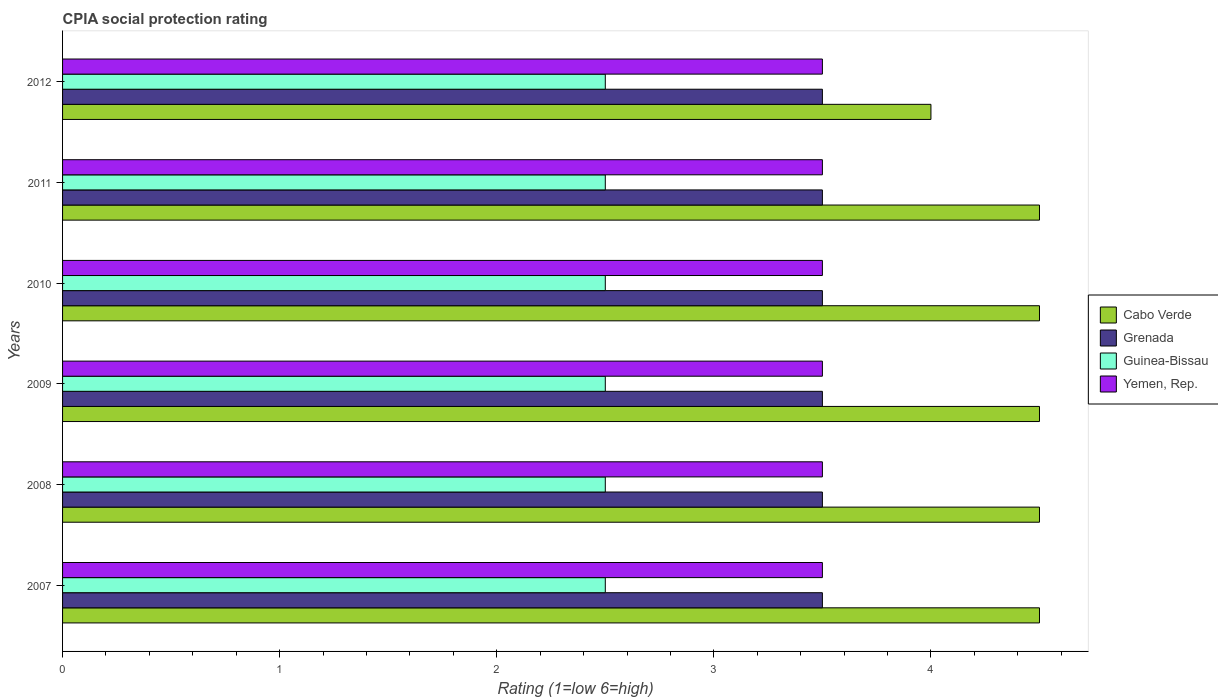How many different coloured bars are there?
Your response must be concise. 4. Are the number of bars per tick equal to the number of legend labels?
Make the answer very short. Yes. How many bars are there on the 2nd tick from the bottom?
Make the answer very short. 4. In how many cases, is the number of bars for a given year not equal to the number of legend labels?
Your response must be concise. 0. What is the CPIA rating in Cabo Verde in 2008?
Ensure brevity in your answer.  4.5. Across all years, what is the maximum CPIA rating in Grenada?
Your answer should be compact. 3.5. Across all years, what is the minimum CPIA rating in Grenada?
Offer a terse response. 3.5. In which year was the CPIA rating in Guinea-Bissau minimum?
Ensure brevity in your answer.  2007. What is the average CPIA rating in Cabo Verde per year?
Your answer should be very brief. 4.42. In the year 2012, what is the difference between the CPIA rating in Cabo Verde and CPIA rating in Guinea-Bissau?
Provide a short and direct response. 1.5. What is the ratio of the CPIA rating in Yemen, Rep. in 2009 to that in 2011?
Your answer should be compact. 1. Is the CPIA rating in Cabo Verde in 2007 less than that in 2008?
Your response must be concise. No. Is the difference between the CPIA rating in Cabo Verde in 2008 and 2011 greater than the difference between the CPIA rating in Guinea-Bissau in 2008 and 2011?
Give a very brief answer. No. Is it the case that in every year, the sum of the CPIA rating in Yemen, Rep. and CPIA rating in Grenada is greater than the sum of CPIA rating in Guinea-Bissau and CPIA rating in Cabo Verde?
Offer a very short reply. Yes. What does the 2nd bar from the top in 2012 represents?
Your answer should be compact. Guinea-Bissau. What does the 3rd bar from the bottom in 2010 represents?
Make the answer very short. Guinea-Bissau. Is it the case that in every year, the sum of the CPIA rating in Guinea-Bissau and CPIA rating in Yemen, Rep. is greater than the CPIA rating in Grenada?
Provide a short and direct response. Yes. How many bars are there?
Provide a short and direct response. 24. Does the graph contain any zero values?
Provide a succinct answer. No. Does the graph contain grids?
Your response must be concise. No. Where does the legend appear in the graph?
Provide a succinct answer. Center right. How are the legend labels stacked?
Make the answer very short. Vertical. What is the title of the graph?
Provide a succinct answer. CPIA social protection rating. What is the label or title of the X-axis?
Make the answer very short. Rating (1=low 6=high). What is the label or title of the Y-axis?
Your answer should be very brief. Years. What is the Rating (1=low 6=high) in Grenada in 2007?
Offer a terse response. 3.5. What is the Rating (1=low 6=high) in Guinea-Bissau in 2007?
Your response must be concise. 2.5. What is the Rating (1=low 6=high) of Yemen, Rep. in 2007?
Keep it short and to the point. 3.5. What is the Rating (1=low 6=high) in Cabo Verde in 2008?
Your answer should be compact. 4.5. What is the Rating (1=low 6=high) in Grenada in 2008?
Your answer should be compact. 3.5. What is the Rating (1=low 6=high) in Yemen, Rep. in 2008?
Your answer should be compact. 3.5. What is the Rating (1=low 6=high) of Cabo Verde in 2009?
Offer a very short reply. 4.5. What is the Rating (1=low 6=high) in Guinea-Bissau in 2009?
Give a very brief answer. 2.5. What is the Rating (1=low 6=high) of Yemen, Rep. in 2009?
Your answer should be compact. 3.5. What is the Rating (1=low 6=high) of Cabo Verde in 2011?
Make the answer very short. 4.5. What is the Rating (1=low 6=high) in Grenada in 2011?
Keep it short and to the point. 3.5. What is the Rating (1=low 6=high) of Cabo Verde in 2012?
Your answer should be compact. 4. What is the Rating (1=low 6=high) of Guinea-Bissau in 2012?
Provide a short and direct response. 2.5. What is the Rating (1=low 6=high) in Yemen, Rep. in 2012?
Your answer should be very brief. 3.5. Across all years, what is the maximum Rating (1=low 6=high) in Yemen, Rep.?
Your response must be concise. 3.5. Across all years, what is the minimum Rating (1=low 6=high) of Cabo Verde?
Your answer should be very brief. 4. Across all years, what is the minimum Rating (1=low 6=high) of Guinea-Bissau?
Ensure brevity in your answer.  2.5. What is the total Rating (1=low 6=high) in Cabo Verde in the graph?
Offer a terse response. 26.5. What is the total Rating (1=low 6=high) of Grenada in the graph?
Your answer should be very brief. 21. What is the total Rating (1=low 6=high) in Yemen, Rep. in the graph?
Make the answer very short. 21. What is the difference between the Rating (1=low 6=high) in Cabo Verde in 2007 and that in 2008?
Keep it short and to the point. 0. What is the difference between the Rating (1=low 6=high) in Grenada in 2007 and that in 2008?
Provide a succinct answer. 0. What is the difference between the Rating (1=low 6=high) in Guinea-Bissau in 2007 and that in 2008?
Offer a terse response. 0. What is the difference between the Rating (1=low 6=high) of Cabo Verde in 2007 and that in 2009?
Your response must be concise. 0. What is the difference between the Rating (1=low 6=high) of Yemen, Rep. in 2007 and that in 2009?
Provide a short and direct response. 0. What is the difference between the Rating (1=low 6=high) of Grenada in 2007 and that in 2010?
Your answer should be compact. 0. What is the difference between the Rating (1=low 6=high) of Grenada in 2007 and that in 2011?
Ensure brevity in your answer.  0. What is the difference between the Rating (1=low 6=high) of Guinea-Bissau in 2007 and that in 2011?
Give a very brief answer. 0. What is the difference between the Rating (1=low 6=high) in Yemen, Rep. in 2007 and that in 2011?
Your answer should be compact. 0. What is the difference between the Rating (1=low 6=high) in Guinea-Bissau in 2007 and that in 2012?
Your answer should be very brief. 0. What is the difference between the Rating (1=low 6=high) in Yemen, Rep. in 2007 and that in 2012?
Your answer should be very brief. 0. What is the difference between the Rating (1=low 6=high) in Grenada in 2008 and that in 2009?
Offer a very short reply. 0. What is the difference between the Rating (1=low 6=high) of Guinea-Bissau in 2008 and that in 2010?
Your answer should be very brief. 0. What is the difference between the Rating (1=low 6=high) of Grenada in 2008 and that in 2011?
Provide a short and direct response. 0. What is the difference between the Rating (1=low 6=high) of Yemen, Rep. in 2008 and that in 2011?
Make the answer very short. 0. What is the difference between the Rating (1=low 6=high) of Guinea-Bissau in 2008 and that in 2012?
Ensure brevity in your answer.  0. What is the difference between the Rating (1=low 6=high) of Cabo Verde in 2009 and that in 2010?
Your answer should be very brief. 0. What is the difference between the Rating (1=low 6=high) in Guinea-Bissau in 2009 and that in 2010?
Ensure brevity in your answer.  0. What is the difference between the Rating (1=low 6=high) of Cabo Verde in 2009 and that in 2011?
Provide a succinct answer. 0. What is the difference between the Rating (1=low 6=high) in Grenada in 2009 and that in 2011?
Provide a short and direct response. 0. What is the difference between the Rating (1=low 6=high) of Yemen, Rep. in 2009 and that in 2011?
Provide a succinct answer. 0. What is the difference between the Rating (1=low 6=high) in Cabo Verde in 2009 and that in 2012?
Provide a succinct answer. 0.5. What is the difference between the Rating (1=low 6=high) in Grenada in 2009 and that in 2012?
Provide a short and direct response. 0. What is the difference between the Rating (1=low 6=high) in Guinea-Bissau in 2009 and that in 2012?
Keep it short and to the point. 0. What is the difference between the Rating (1=low 6=high) in Yemen, Rep. in 2009 and that in 2012?
Offer a terse response. 0. What is the difference between the Rating (1=low 6=high) of Grenada in 2010 and that in 2012?
Your answer should be very brief. 0. What is the difference between the Rating (1=low 6=high) of Guinea-Bissau in 2010 and that in 2012?
Keep it short and to the point. 0. What is the difference between the Rating (1=low 6=high) of Yemen, Rep. in 2010 and that in 2012?
Offer a terse response. 0. What is the difference between the Rating (1=low 6=high) in Cabo Verde in 2011 and that in 2012?
Your answer should be very brief. 0.5. What is the difference between the Rating (1=low 6=high) of Cabo Verde in 2007 and the Rating (1=low 6=high) of Grenada in 2008?
Give a very brief answer. 1. What is the difference between the Rating (1=low 6=high) in Cabo Verde in 2007 and the Rating (1=low 6=high) in Yemen, Rep. in 2008?
Make the answer very short. 1. What is the difference between the Rating (1=low 6=high) in Grenada in 2007 and the Rating (1=low 6=high) in Guinea-Bissau in 2008?
Your answer should be very brief. 1. What is the difference between the Rating (1=low 6=high) in Grenada in 2007 and the Rating (1=low 6=high) in Yemen, Rep. in 2008?
Offer a very short reply. 0. What is the difference between the Rating (1=low 6=high) of Cabo Verde in 2007 and the Rating (1=low 6=high) of Guinea-Bissau in 2009?
Make the answer very short. 2. What is the difference between the Rating (1=low 6=high) of Grenada in 2007 and the Rating (1=low 6=high) of Yemen, Rep. in 2009?
Keep it short and to the point. 0. What is the difference between the Rating (1=low 6=high) of Guinea-Bissau in 2007 and the Rating (1=low 6=high) of Yemen, Rep. in 2009?
Keep it short and to the point. -1. What is the difference between the Rating (1=low 6=high) in Cabo Verde in 2007 and the Rating (1=low 6=high) in Yemen, Rep. in 2010?
Your answer should be very brief. 1. What is the difference between the Rating (1=low 6=high) of Grenada in 2007 and the Rating (1=low 6=high) of Guinea-Bissau in 2010?
Provide a short and direct response. 1. What is the difference between the Rating (1=low 6=high) in Grenada in 2007 and the Rating (1=low 6=high) in Yemen, Rep. in 2010?
Keep it short and to the point. 0. What is the difference between the Rating (1=low 6=high) of Guinea-Bissau in 2007 and the Rating (1=low 6=high) of Yemen, Rep. in 2010?
Ensure brevity in your answer.  -1. What is the difference between the Rating (1=low 6=high) of Cabo Verde in 2007 and the Rating (1=low 6=high) of Yemen, Rep. in 2011?
Ensure brevity in your answer.  1. What is the difference between the Rating (1=low 6=high) of Cabo Verde in 2007 and the Rating (1=low 6=high) of Grenada in 2012?
Provide a succinct answer. 1. What is the difference between the Rating (1=low 6=high) in Cabo Verde in 2007 and the Rating (1=low 6=high) in Guinea-Bissau in 2012?
Make the answer very short. 2. What is the difference between the Rating (1=low 6=high) of Grenada in 2007 and the Rating (1=low 6=high) of Guinea-Bissau in 2012?
Your answer should be very brief. 1. What is the difference between the Rating (1=low 6=high) of Guinea-Bissau in 2007 and the Rating (1=low 6=high) of Yemen, Rep. in 2012?
Give a very brief answer. -1. What is the difference between the Rating (1=low 6=high) of Cabo Verde in 2008 and the Rating (1=low 6=high) of Grenada in 2009?
Your answer should be very brief. 1. What is the difference between the Rating (1=low 6=high) in Cabo Verde in 2008 and the Rating (1=low 6=high) in Guinea-Bissau in 2009?
Keep it short and to the point. 2. What is the difference between the Rating (1=low 6=high) in Cabo Verde in 2008 and the Rating (1=low 6=high) in Yemen, Rep. in 2009?
Make the answer very short. 1. What is the difference between the Rating (1=low 6=high) of Grenada in 2008 and the Rating (1=low 6=high) of Guinea-Bissau in 2009?
Offer a very short reply. 1. What is the difference between the Rating (1=low 6=high) in Guinea-Bissau in 2008 and the Rating (1=low 6=high) in Yemen, Rep. in 2009?
Provide a succinct answer. -1. What is the difference between the Rating (1=low 6=high) of Cabo Verde in 2008 and the Rating (1=low 6=high) of Grenada in 2010?
Your answer should be compact. 1. What is the difference between the Rating (1=low 6=high) in Cabo Verde in 2008 and the Rating (1=low 6=high) in Guinea-Bissau in 2010?
Your answer should be very brief. 2. What is the difference between the Rating (1=low 6=high) in Cabo Verde in 2008 and the Rating (1=low 6=high) in Yemen, Rep. in 2010?
Provide a short and direct response. 1. What is the difference between the Rating (1=low 6=high) of Grenada in 2008 and the Rating (1=low 6=high) of Guinea-Bissau in 2010?
Ensure brevity in your answer.  1. What is the difference between the Rating (1=low 6=high) of Grenada in 2008 and the Rating (1=low 6=high) of Yemen, Rep. in 2010?
Offer a terse response. 0. What is the difference between the Rating (1=low 6=high) in Cabo Verde in 2008 and the Rating (1=low 6=high) in Grenada in 2011?
Make the answer very short. 1. What is the difference between the Rating (1=low 6=high) of Grenada in 2008 and the Rating (1=low 6=high) of Guinea-Bissau in 2011?
Provide a succinct answer. 1. What is the difference between the Rating (1=low 6=high) of Grenada in 2008 and the Rating (1=low 6=high) of Yemen, Rep. in 2011?
Give a very brief answer. 0. What is the difference between the Rating (1=low 6=high) in Cabo Verde in 2008 and the Rating (1=low 6=high) in Grenada in 2012?
Your answer should be very brief. 1. What is the difference between the Rating (1=low 6=high) in Cabo Verde in 2008 and the Rating (1=low 6=high) in Yemen, Rep. in 2012?
Provide a short and direct response. 1. What is the difference between the Rating (1=low 6=high) of Grenada in 2008 and the Rating (1=low 6=high) of Guinea-Bissau in 2012?
Make the answer very short. 1. What is the difference between the Rating (1=low 6=high) in Grenada in 2008 and the Rating (1=low 6=high) in Yemen, Rep. in 2012?
Your answer should be very brief. 0. What is the difference between the Rating (1=low 6=high) of Cabo Verde in 2009 and the Rating (1=low 6=high) of Guinea-Bissau in 2010?
Your answer should be compact. 2. What is the difference between the Rating (1=low 6=high) in Cabo Verde in 2009 and the Rating (1=low 6=high) in Yemen, Rep. in 2010?
Your answer should be compact. 1. What is the difference between the Rating (1=low 6=high) in Grenada in 2009 and the Rating (1=low 6=high) in Guinea-Bissau in 2010?
Provide a succinct answer. 1. What is the difference between the Rating (1=low 6=high) of Guinea-Bissau in 2009 and the Rating (1=low 6=high) of Yemen, Rep. in 2010?
Give a very brief answer. -1. What is the difference between the Rating (1=low 6=high) in Cabo Verde in 2009 and the Rating (1=low 6=high) in Guinea-Bissau in 2011?
Make the answer very short. 2. What is the difference between the Rating (1=low 6=high) in Cabo Verde in 2009 and the Rating (1=low 6=high) in Yemen, Rep. in 2011?
Your answer should be compact. 1. What is the difference between the Rating (1=low 6=high) in Grenada in 2009 and the Rating (1=low 6=high) in Guinea-Bissau in 2011?
Ensure brevity in your answer.  1. What is the difference between the Rating (1=low 6=high) of Cabo Verde in 2009 and the Rating (1=low 6=high) of Grenada in 2012?
Your response must be concise. 1. What is the difference between the Rating (1=low 6=high) in Cabo Verde in 2009 and the Rating (1=low 6=high) in Guinea-Bissau in 2012?
Your answer should be very brief. 2. What is the difference between the Rating (1=low 6=high) of Cabo Verde in 2009 and the Rating (1=low 6=high) of Yemen, Rep. in 2012?
Your answer should be very brief. 1. What is the difference between the Rating (1=low 6=high) in Cabo Verde in 2010 and the Rating (1=low 6=high) in Guinea-Bissau in 2011?
Keep it short and to the point. 2. What is the difference between the Rating (1=low 6=high) of Grenada in 2010 and the Rating (1=low 6=high) of Guinea-Bissau in 2011?
Your response must be concise. 1. What is the difference between the Rating (1=low 6=high) in Guinea-Bissau in 2010 and the Rating (1=low 6=high) in Yemen, Rep. in 2011?
Your answer should be very brief. -1. What is the difference between the Rating (1=low 6=high) in Cabo Verde in 2010 and the Rating (1=low 6=high) in Guinea-Bissau in 2012?
Provide a succinct answer. 2. What is the difference between the Rating (1=low 6=high) of Cabo Verde in 2010 and the Rating (1=low 6=high) of Yemen, Rep. in 2012?
Offer a very short reply. 1. What is the difference between the Rating (1=low 6=high) of Grenada in 2010 and the Rating (1=low 6=high) of Guinea-Bissau in 2012?
Provide a succinct answer. 1. What is the difference between the Rating (1=low 6=high) of Guinea-Bissau in 2010 and the Rating (1=low 6=high) of Yemen, Rep. in 2012?
Your response must be concise. -1. What is the difference between the Rating (1=low 6=high) in Cabo Verde in 2011 and the Rating (1=low 6=high) in Guinea-Bissau in 2012?
Provide a short and direct response. 2. What is the difference between the Rating (1=low 6=high) in Cabo Verde in 2011 and the Rating (1=low 6=high) in Yemen, Rep. in 2012?
Provide a short and direct response. 1. What is the difference between the Rating (1=low 6=high) in Grenada in 2011 and the Rating (1=low 6=high) in Guinea-Bissau in 2012?
Ensure brevity in your answer.  1. What is the difference between the Rating (1=low 6=high) in Guinea-Bissau in 2011 and the Rating (1=low 6=high) in Yemen, Rep. in 2012?
Make the answer very short. -1. What is the average Rating (1=low 6=high) of Cabo Verde per year?
Ensure brevity in your answer.  4.42. What is the average Rating (1=low 6=high) in Guinea-Bissau per year?
Offer a terse response. 2.5. In the year 2007, what is the difference between the Rating (1=low 6=high) in Cabo Verde and Rating (1=low 6=high) in Guinea-Bissau?
Offer a very short reply. 2. In the year 2007, what is the difference between the Rating (1=low 6=high) in Cabo Verde and Rating (1=low 6=high) in Yemen, Rep.?
Give a very brief answer. 1. In the year 2007, what is the difference between the Rating (1=low 6=high) of Grenada and Rating (1=low 6=high) of Guinea-Bissau?
Provide a succinct answer. 1. In the year 2007, what is the difference between the Rating (1=low 6=high) of Grenada and Rating (1=low 6=high) of Yemen, Rep.?
Your answer should be compact. 0. In the year 2008, what is the difference between the Rating (1=low 6=high) of Cabo Verde and Rating (1=low 6=high) of Guinea-Bissau?
Make the answer very short. 2. In the year 2009, what is the difference between the Rating (1=low 6=high) in Cabo Verde and Rating (1=low 6=high) in Guinea-Bissau?
Your response must be concise. 2. In the year 2009, what is the difference between the Rating (1=low 6=high) of Guinea-Bissau and Rating (1=low 6=high) of Yemen, Rep.?
Your answer should be compact. -1. In the year 2010, what is the difference between the Rating (1=low 6=high) in Cabo Verde and Rating (1=low 6=high) in Grenada?
Ensure brevity in your answer.  1. In the year 2010, what is the difference between the Rating (1=low 6=high) of Cabo Verde and Rating (1=low 6=high) of Guinea-Bissau?
Your answer should be compact. 2. In the year 2010, what is the difference between the Rating (1=low 6=high) of Grenada and Rating (1=low 6=high) of Guinea-Bissau?
Your answer should be compact. 1. In the year 2010, what is the difference between the Rating (1=low 6=high) of Guinea-Bissau and Rating (1=low 6=high) of Yemen, Rep.?
Provide a short and direct response. -1. In the year 2011, what is the difference between the Rating (1=low 6=high) in Cabo Verde and Rating (1=low 6=high) in Guinea-Bissau?
Keep it short and to the point. 2. In the year 2011, what is the difference between the Rating (1=low 6=high) of Grenada and Rating (1=low 6=high) of Yemen, Rep.?
Keep it short and to the point. 0. In the year 2011, what is the difference between the Rating (1=low 6=high) in Guinea-Bissau and Rating (1=low 6=high) in Yemen, Rep.?
Ensure brevity in your answer.  -1. In the year 2012, what is the difference between the Rating (1=low 6=high) in Cabo Verde and Rating (1=low 6=high) in Guinea-Bissau?
Provide a succinct answer. 1.5. In the year 2012, what is the difference between the Rating (1=low 6=high) in Grenada and Rating (1=low 6=high) in Guinea-Bissau?
Offer a terse response. 1. In the year 2012, what is the difference between the Rating (1=low 6=high) in Guinea-Bissau and Rating (1=low 6=high) in Yemen, Rep.?
Your answer should be compact. -1. What is the ratio of the Rating (1=low 6=high) in Yemen, Rep. in 2007 to that in 2008?
Keep it short and to the point. 1. What is the ratio of the Rating (1=low 6=high) of Cabo Verde in 2007 to that in 2009?
Provide a succinct answer. 1. What is the ratio of the Rating (1=low 6=high) of Grenada in 2007 to that in 2009?
Your answer should be compact. 1. What is the ratio of the Rating (1=low 6=high) in Guinea-Bissau in 2007 to that in 2009?
Your answer should be very brief. 1. What is the ratio of the Rating (1=low 6=high) in Yemen, Rep. in 2007 to that in 2009?
Keep it short and to the point. 1. What is the ratio of the Rating (1=low 6=high) in Guinea-Bissau in 2007 to that in 2010?
Ensure brevity in your answer.  1. What is the ratio of the Rating (1=low 6=high) of Yemen, Rep. in 2007 to that in 2010?
Make the answer very short. 1. What is the ratio of the Rating (1=low 6=high) in Guinea-Bissau in 2007 to that in 2011?
Your answer should be very brief. 1. What is the ratio of the Rating (1=low 6=high) in Yemen, Rep. in 2007 to that in 2011?
Keep it short and to the point. 1. What is the ratio of the Rating (1=low 6=high) in Yemen, Rep. in 2007 to that in 2012?
Keep it short and to the point. 1. What is the ratio of the Rating (1=low 6=high) in Grenada in 2008 to that in 2009?
Offer a very short reply. 1. What is the ratio of the Rating (1=low 6=high) of Grenada in 2008 to that in 2010?
Give a very brief answer. 1. What is the ratio of the Rating (1=low 6=high) in Yemen, Rep. in 2008 to that in 2010?
Provide a short and direct response. 1. What is the ratio of the Rating (1=low 6=high) of Cabo Verde in 2008 to that in 2011?
Make the answer very short. 1. What is the ratio of the Rating (1=low 6=high) of Guinea-Bissau in 2008 to that in 2011?
Your answer should be compact. 1. What is the ratio of the Rating (1=low 6=high) of Yemen, Rep. in 2008 to that in 2011?
Ensure brevity in your answer.  1. What is the ratio of the Rating (1=low 6=high) in Grenada in 2008 to that in 2012?
Your answer should be compact. 1. What is the ratio of the Rating (1=low 6=high) in Cabo Verde in 2009 to that in 2010?
Offer a very short reply. 1. What is the ratio of the Rating (1=low 6=high) in Grenada in 2009 to that in 2010?
Make the answer very short. 1. What is the ratio of the Rating (1=low 6=high) of Yemen, Rep. in 2009 to that in 2010?
Provide a short and direct response. 1. What is the ratio of the Rating (1=low 6=high) in Grenada in 2009 to that in 2011?
Provide a succinct answer. 1. What is the ratio of the Rating (1=low 6=high) in Guinea-Bissau in 2009 to that in 2011?
Provide a short and direct response. 1. What is the ratio of the Rating (1=low 6=high) of Yemen, Rep. in 2009 to that in 2011?
Make the answer very short. 1. What is the ratio of the Rating (1=low 6=high) in Cabo Verde in 2009 to that in 2012?
Provide a short and direct response. 1.12. What is the ratio of the Rating (1=low 6=high) in Cabo Verde in 2010 to that in 2011?
Make the answer very short. 1. What is the ratio of the Rating (1=low 6=high) of Guinea-Bissau in 2010 to that in 2011?
Offer a very short reply. 1. What is the ratio of the Rating (1=low 6=high) of Yemen, Rep. in 2010 to that in 2011?
Keep it short and to the point. 1. What is the ratio of the Rating (1=low 6=high) of Grenada in 2010 to that in 2012?
Offer a very short reply. 1. What is the ratio of the Rating (1=low 6=high) in Guinea-Bissau in 2010 to that in 2012?
Provide a succinct answer. 1. What is the ratio of the Rating (1=low 6=high) in Cabo Verde in 2011 to that in 2012?
Your answer should be compact. 1.12. What is the ratio of the Rating (1=low 6=high) in Guinea-Bissau in 2011 to that in 2012?
Your answer should be very brief. 1. What is the difference between the highest and the second highest Rating (1=low 6=high) in Guinea-Bissau?
Provide a succinct answer. 0. What is the difference between the highest and the second highest Rating (1=low 6=high) in Yemen, Rep.?
Provide a short and direct response. 0. What is the difference between the highest and the lowest Rating (1=low 6=high) of Grenada?
Make the answer very short. 0. What is the difference between the highest and the lowest Rating (1=low 6=high) of Guinea-Bissau?
Provide a succinct answer. 0. 